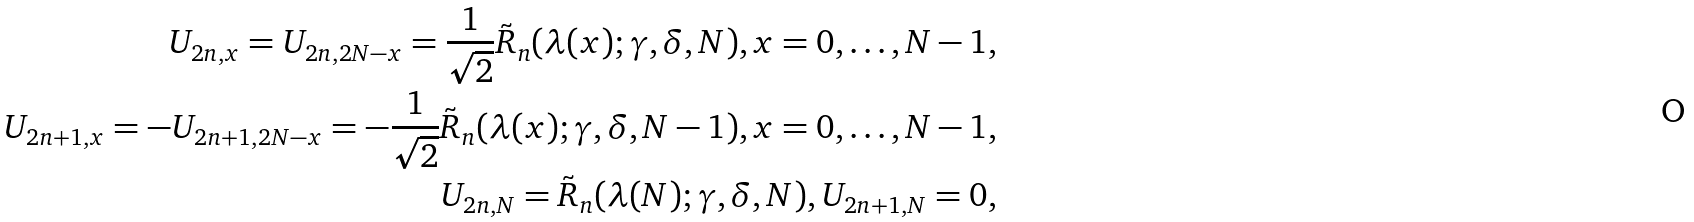Convert formula to latex. <formula><loc_0><loc_0><loc_500><loc_500>U _ { 2 n , x } = U _ { 2 n , 2 N - x } = \frac { 1 } { \sqrt { 2 } } \tilde { R } _ { n } ( \lambda ( x ) ; \gamma , \delta , N ) , x = 0 , \dots , N - 1 , \\ U _ { 2 n + 1 , x } = - U _ { 2 n + 1 , 2 N - x } = - \frac { 1 } { \sqrt { 2 } } \tilde { R } _ { n } ( \lambda ( x ) ; \gamma , \delta , N - 1 ) , x = 0 , \dots , N - 1 , \\ U _ { 2 n , N } = \tilde { R } _ { n } ( \lambda ( N ) ; \gamma , \delta , N ) , U _ { 2 n + 1 , N } = 0 ,</formula> 